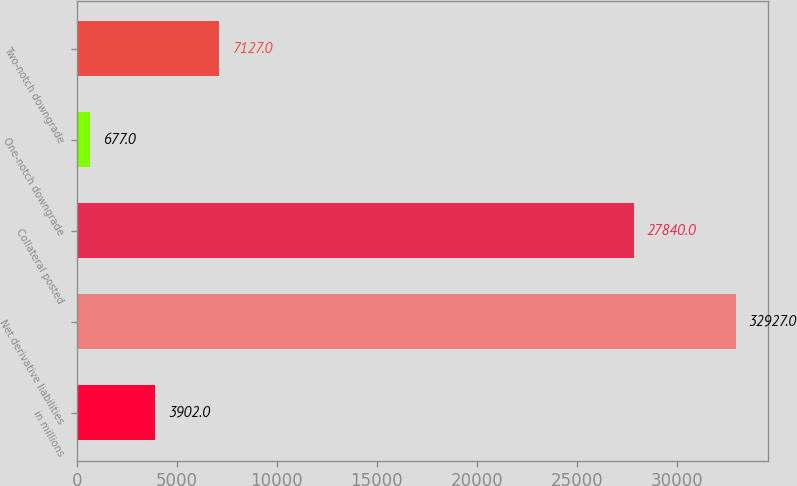Convert chart. <chart><loc_0><loc_0><loc_500><loc_500><bar_chart><fcel>in millions<fcel>Net derivative liabilities<fcel>Collateral posted<fcel>One-notch downgrade<fcel>Two-notch downgrade<nl><fcel>3902<fcel>32927<fcel>27840<fcel>677<fcel>7127<nl></chart> 